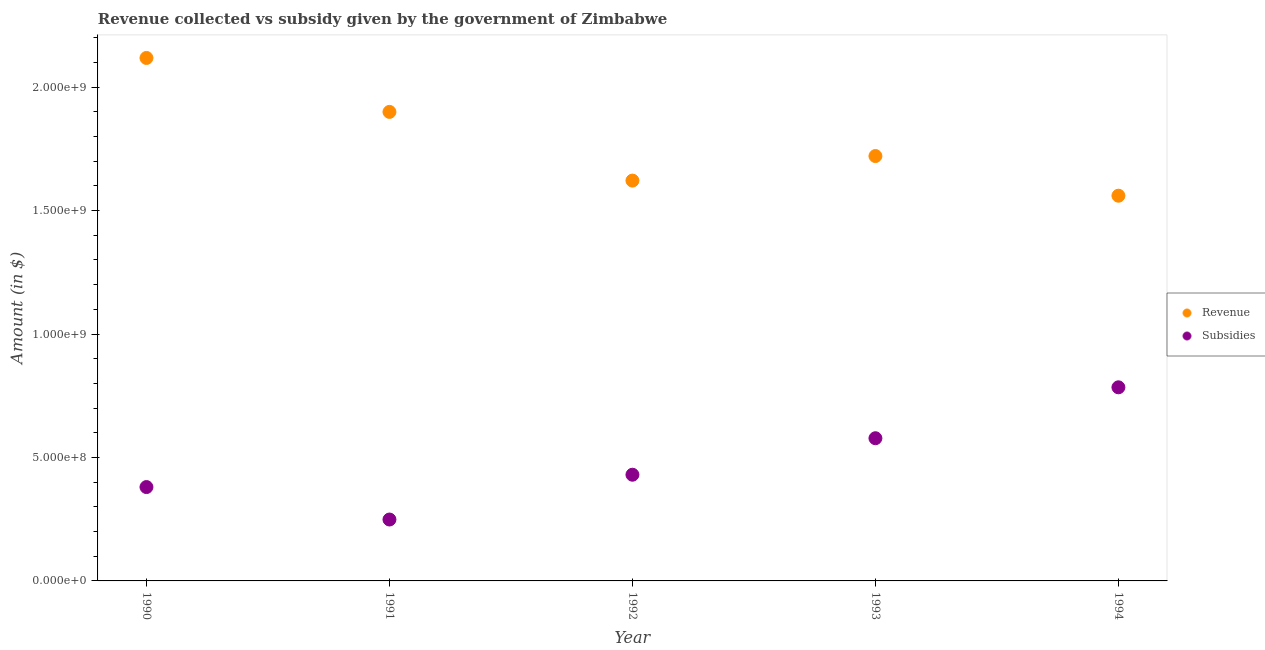What is the amount of subsidies given in 1993?
Give a very brief answer. 5.78e+08. Across all years, what is the maximum amount of revenue collected?
Offer a terse response. 2.12e+09. Across all years, what is the minimum amount of revenue collected?
Offer a very short reply. 1.56e+09. In which year was the amount of subsidies given maximum?
Ensure brevity in your answer.  1994. What is the total amount of revenue collected in the graph?
Make the answer very short. 8.92e+09. What is the difference between the amount of revenue collected in 1991 and that in 1993?
Provide a short and direct response. 1.79e+08. What is the difference between the amount of subsidies given in 1990 and the amount of revenue collected in 1992?
Your answer should be very brief. -1.24e+09. What is the average amount of subsidies given per year?
Your answer should be very brief. 4.84e+08. In the year 1994, what is the difference between the amount of subsidies given and amount of revenue collected?
Offer a very short reply. -7.76e+08. In how many years, is the amount of revenue collected greater than 1200000000 $?
Provide a succinct answer. 5. What is the ratio of the amount of revenue collected in 1990 to that in 1991?
Give a very brief answer. 1.12. Is the amount of subsidies given in 1990 less than that in 1993?
Offer a very short reply. Yes. What is the difference between the highest and the second highest amount of subsidies given?
Your response must be concise. 2.06e+08. What is the difference between the highest and the lowest amount of revenue collected?
Ensure brevity in your answer.  5.58e+08. In how many years, is the amount of subsidies given greater than the average amount of subsidies given taken over all years?
Your response must be concise. 2. Is the sum of the amount of revenue collected in 1990 and 1992 greater than the maximum amount of subsidies given across all years?
Your response must be concise. Yes. Does the amount of subsidies given monotonically increase over the years?
Make the answer very short. No. Is the amount of subsidies given strictly greater than the amount of revenue collected over the years?
Your answer should be compact. No. Is the amount of subsidies given strictly less than the amount of revenue collected over the years?
Offer a terse response. Yes. Are the values on the major ticks of Y-axis written in scientific E-notation?
Provide a succinct answer. Yes. How many legend labels are there?
Offer a terse response. 2. How are the legend labels stacked?
Provide a succinct answer. Vertical. What is the title of the graph?
Your answer should be very brief. Revenue collected vs subsidy given by the government of Zimbabwe. What is the label or title of the X-axis?
Your answer should be very brief. Year. What is the label or title of the Y-axis?
Your answer should be compact. Amount (in $). What is the Amount (in $) of Revenue in 1990?
Give a very brief answer. 2.12e+09. What is the Amount (in $) of Subsidies in 1990?
Make the answer very short. 3.80e+08. What is the Amount (in $) in Revenue in 1991?
Make the answer very short. 1.90e+09. What is the Amount (in $) in Subsidies in 1991?
Provide a succinct answer. 2.49e+08. What is the Amount (in $) of Revenue in 1992?
Keep it short and to the point. 1.62e+09. What is the Amount (in $) in Subsidies in 1992?
Offer a terse response. 4.30e+08. What is the Amount (in $) of Revenue in 1993?
Ensure brevity in your answer.  1.72e+09. What is the Amount (in $) in Subsidies in 1993?
Give a very brief answer. 5.78e+08. What is the Amount (in $) of Revenue in 1994?
Provide a short and direct response. 1.56e+09. What is the Amount (in $) in Subsidies in 1994?
Provide a short and direct response. 7.84e+08. Across all years, what is the maximum Amount (in $) in Revenue?
Keep it short and to the point. 2.12e+09. Across all years, what is the maximum Amount (in $) in Subsidies?
Your answer should be compact. 7.84e+08. Across all years, what is the minimum Amount (in $) of Revenue?
Provide a succinct answer. 1.56e+09. Across all years, what is the minimum Amount (in $) of Subsidies?
Provide a short and direct response. 2.49e+08. What is the total Amount (in $) in Revenue in the graph?
Ensure brevity in your answer.  8.92e+09. What is the total Amount (in $) of Subsidies in the graph?
Provide a succinct answer. 2.42e+09. What is the difference between the Amount (in $) in Revenue in 1990 and that in 1991?
Your answer should be compact. 2.19e+08. What is the difference between the Amount (in $) of Subsidies in 1990 and that in 1991?
Provide a short and direct response. 1.31e+08. What is the difference between the Amount (in $) of Revenue in 1990 and that in 1992?
Your answer should be compact. 4.97e+08. What is the difference between the Amount (in $) in Subsidies in 1990 and that in 1992?
Keep it short and to the point. -5.00e+07. What is the difference between the Amount (in $) in Revenue in 1990 and that in 1993?
Your answer should be compact. 3.97e+08. What is the difference between the Amount (in $) of Subsidies in 1990 and that in 1993?
Offer a very short reply. -1.98e+08. What is the difference between the Amount (in $) of Revenue in 1990 and that in 1994?
Offer a terse response. 5.58e+08. What is the difference between the Amount (in $) in Subsidies in 1990 and that in 1994?
Your answer should be very brief. -4.04e+08. What is the difference between the Amount (in $) of Revenue in 1991 and that in 1992?
Keep it short and to the point. 2.78e+08. What is the difference between the Amount (in $) in Subsidies in 1991 and that in 1992?
Offer a terse response. -1.81e+08. What is the difference between the Amount (in $) of Revenue in 1991 and that in 1993?
Provide a succinct answer. 1.79e+08. What is the difference between the Amount (in $) of Subsidies in 1991 and that in 1993?
Provide a succinct answer. -3.29e+08. What is the difference between the Amount (in $) of Revenue in 1991 and that in 1994?
Offer a terse response. 3.39e+08. What is the difference between the Amount (in $) in Subsidies in 1991 and that in 1994?
Your response must be concise. -5.36e+08. What is the difference between the Amount (in $) in Revenue in 1992 and that in 1993?
Your answer should be very brief. -9.95e+07. What is the difference between the Amount (in $) of Subsidies in 1992 and that in 1993?
Offer a terse response. -1.48e+08. What is the difference between the Amount (in $) of Revenue in 1992 and that in 1994?
Your answer should be compact. 6.12e+07. What is the difference between the Amount (in $) of Subsidies in 1992 and that in 1994?
Offer a very short reply. -3.54e+08. What is the difference between the Amount (in $) of Revenue in 1993 and that in 1994?
Your answer should be compact. 1.61e+08. What is the difference between the Amount (in $) in Subsidies in 1993 and that in 1994?
Your answer should be very brief. -2.06e+08. What is the difference between the Amount (in $) of Revenue in 1990 and the Amount (in $) of Subsidies in 1991?
Your answer should be very brief. 1.87e+09. What is the difference between the Amount (in $) in Revenue in 1990 and the Amount (in $) in Subsidies in 1992?
Provide a succinct answer. 1.69e+09. What is the difference between the Amount (in $) in Revenue in 1990 and the Amount (in $) in Subsidies in 1993?
Offer a terse response. 1.54e+09. What is the difference between the Amount (in $) in Revenue in 1990 and the Amount (in $) in Subsidies in 1994?
Keep it short and to the point. 1.33e+09. What is the difference between the Amount (in $) of Revenue in 1991 and the Amount (in $) of Subsidies in 1992?
Your answer should be very brief. 1.47e+09. What is the difference between the Amount (in $) in Revenue in 1991 and the Amount (in $) in Subsidies in 1993?
Give a very brief answer. 1.32e+09. What is the difference between the Amount (in $) in Revenue in 1991 and the Amount (in $) in Subsidies in 1994?
Offer a terse response. 1.12e+09. What is the difference between the Amount (in $) of Revenue in 1992 and the Amount (in $) of Subsidies in 1993?
Keep it short and to the point. 1.04e+09. What is the difference between the Amount (in $) of Revenue in 1992 and the Amount (in $) of Subsidies in 1994?
Provide a short and direct response. 8.37e+08. What is the difference between the Amount (in $) in Revenue in 1993 and the Amount (in $) in Subsidies in 1994?
Provide a short and direct response. 9.37e+08. What is the average Amount (in $) in Revenue per year?
Ensure brevity in your answer.  1.78e+09. What is the average Amount (in $) of Subsidies per year?
Your response must be concise. 4.84e+08. In the year 1990, what is the difference between the Amount (in $) in Revenue and Amount (in $) in Subsidies?
Provide a short and direct response. 1.74e+09. In the year 1991, what is the difference between the Amount (in $) in Revenue and Amount (in $) in Subsidies?
Your response must be concise. 1.65e+09. In the year 1992, what is the difference between the Amount (in $) in Revenue and Amount (in $) in Subsidies?
Make the answer very short. 1.19e+09. In the year 1993, what is the difference between the Amount (in $) in Revenue and Amount (in $) in Subsidies?
Offer a terse response. 1.14e+09. In the year 1994, what is the difference between the Amount (in $) in Revenue and Amount (in $) in Subsidies?
Make the answer very short. 7.76e+08. What is the ratio of the Amount (in $) in Revenue in 1990 to that in 1991?
Offer a terse response. 1.11. What is the ratio of the Amount (in $) in Subsidies in 1990 to that in 1991?
Offer a very short reply. 1.53. What is the ratio of the Amount (in $) in Revenue in 1990 to that in 1992?
Keep it short and to the point. 1.31. What is the ratio of the Amount (in $) in Subsidies in 1990 to that in 1992?
Your answer should be very brief. 0.88. What is the ratio of the Amount (in $) of Revenue in 1990 to that in 1993?
Provide a short and direct response. 1.23. What is the ratio of the Amount (in $) of Subsidies in 1990 to that in 1993?
Offer a very short reply. 0.66. What is the ratio of the Amount (in $) of Revenue in 1990 to that in 1994?
Your answer should be very brief. 1.36. What is the ratio of the Amount (in $) in Subsidies in 1990 to that in 1994?
Your response must be concise. 0.48. What is the ratio of the Amount (in $) in Revenue in 1991 to that in 1992?
Ensure brevity in your answer.  1.17. What is the ratio of the Amount (in $) in Subsidies in 1991 to that in 1992?
Provide a short and direct response. 0.58. What is the ratio of the Amount (in $) in Revenue in 1991 to that in 1993?
Provide a short and direct response. 1.1. What is the ratio of the Amount (in $) in Subsidies in 1991 to that in 1993?
Keep it short and to the point. 0.43. What is the ratio of the Amount (in $) of Revenue in 1991 to that in 1994?
Make the answer very short. 1.22. What is the ratio of the Amount (in $) in Subsidies in 1991 to that in 1994?
Give a very brief answer. 0.32. What is the ratio of the Amount (in $) of Revenue in 1992 to that in 1993?
Offer a terse response. 0.94. What is the ratio of the Amount (in $) in Subsidies in 1992 to that in 1993?
Provide a succinct answer. 0.74. What is the ratio of the Amount (in $) of Revenue in 1992 to that in 1994?
Your answer should be compact. 1.04. What is the ratio of the Amount (in $) of Subsidies in 1992 to that in 1994?
Ensure brevity in your answer.  0.55. What is the ratio of the Amount (in $) of Revenue in 1993 to that in 1994?
Ensure brevity in your answer.  1.1. What is the ratio of the Amount (in $) in Subsidies in 1993 to that in 1994?
Give a very brief answer. 0.74. What is the difference between the highest and the second highest Amount (in $) of Revenue?
Ensure brevity in your answer.  2.19e+08. What is the difference between the highest and the second highest Amount (in $) of Subsidies?
Ensure brevity in your answer.  2.06e+08. What is the difference between the highest and the lowest Amount (in $) of Revenue?
Ensure brevity in your answer.  5.58e+08. What is the difference between the highest and the lowest Amount (in $) of Subsidies?
Provide a short and direct response. 5.36e+08. 